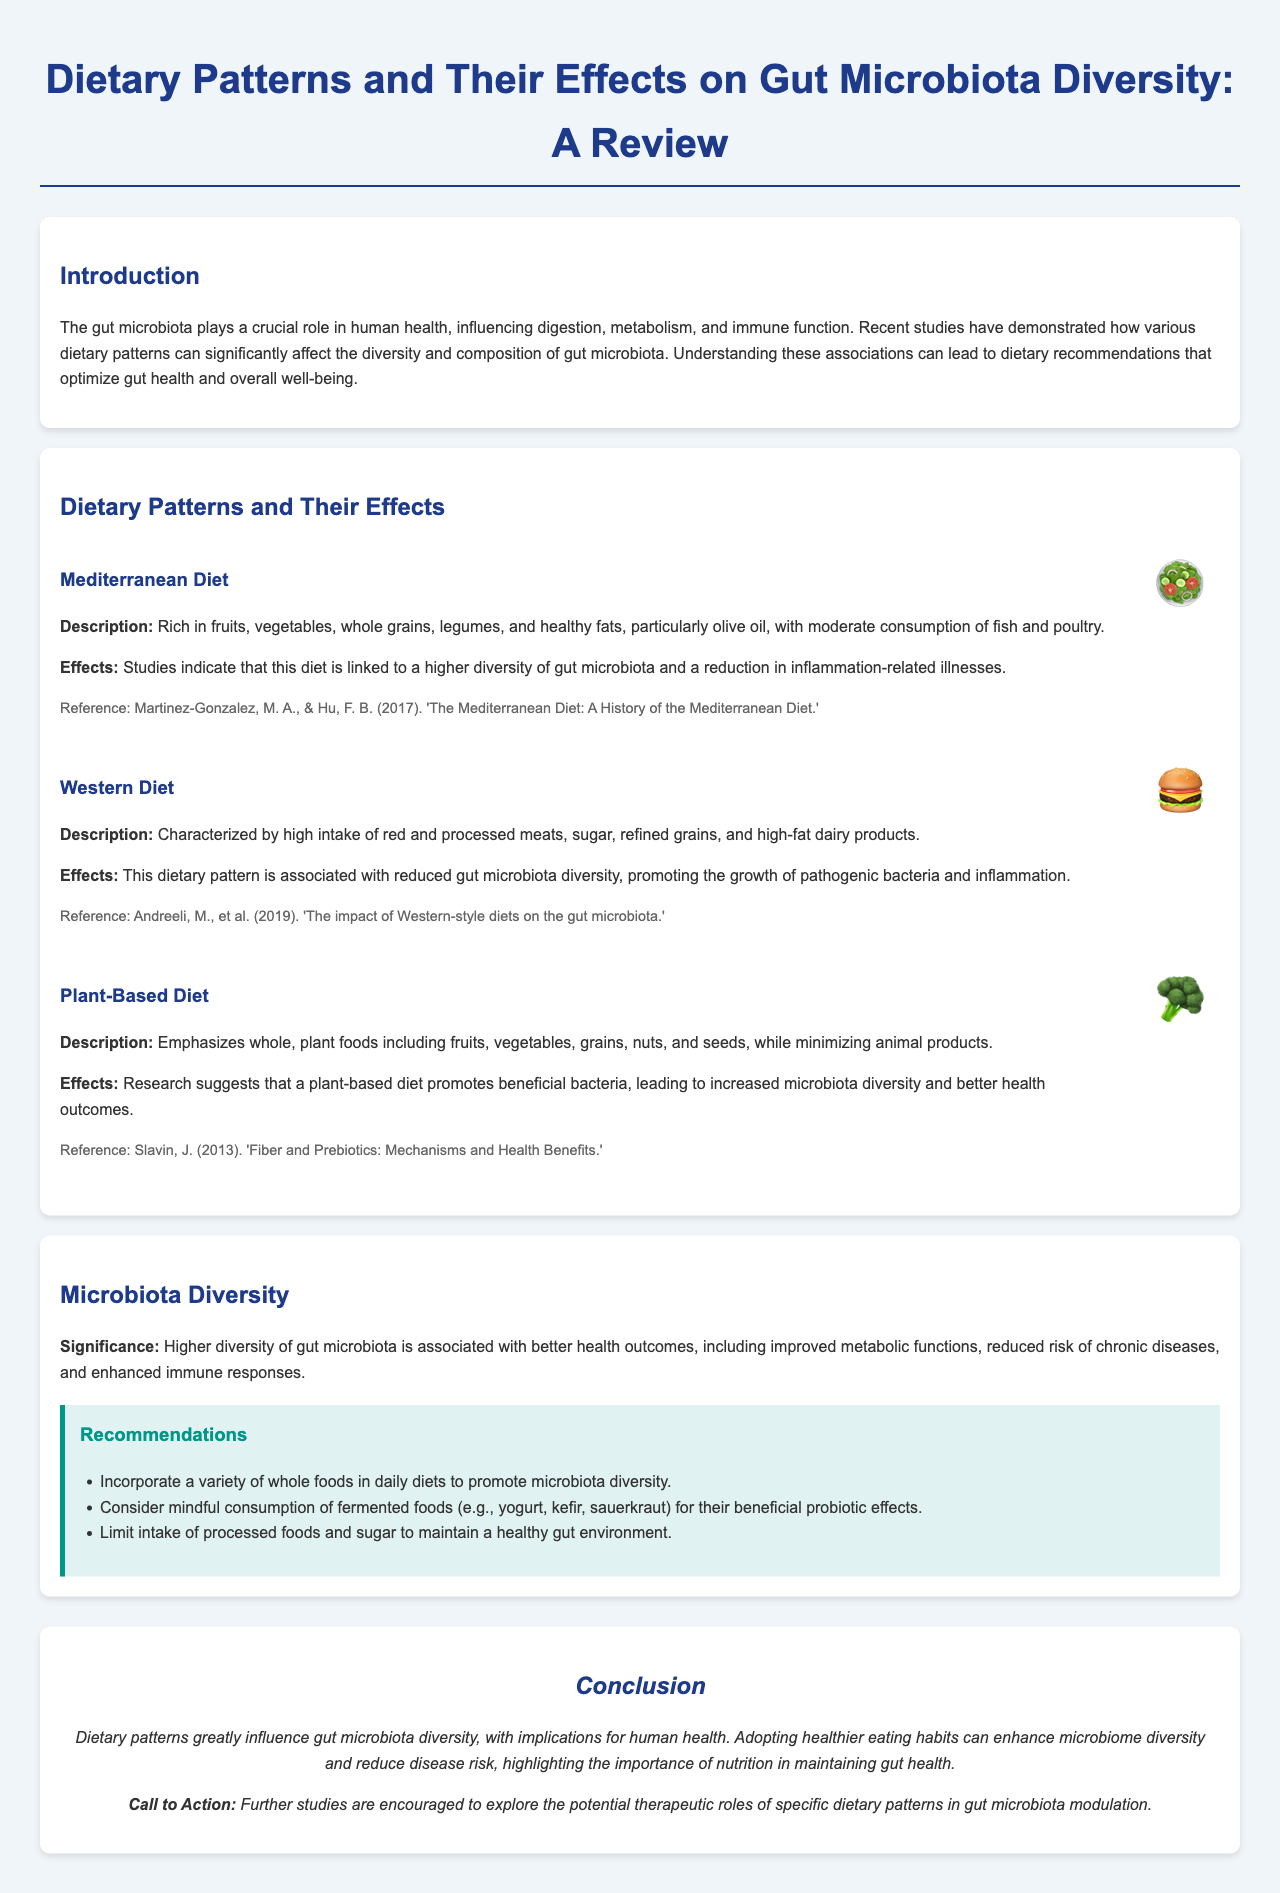What is the main subject of the report? The main subject of the report is the effects of dietary patterns on gut microbiota diversity.
Answer: Dietary patterns and gut microbiota diversity What dietary pattern is associated with higher gut microbiota diversity? The Mediterranean Diet is linked to a higher diversity of gut microbiota.
Answer: Mediterranean Diet What is the effect of the Western Diet on gut microbiota? The Western Diet is associated with reduced gut microbiota diversity.
Answer: Reduced gut microbiota diversity What does a plant-based diet promote? A plant-based diet promotes beneficial bacteria.
Answer: Beneficial bacteria Which foods should be incorporated to promote microbiota diversity? A variety of whole foods should be incorporated into daily diets.
Answer: Variety of whole foods What is the significance of higher gut microbiota diversity? Higher diversity is associated with better health outcomes and reduced risk of chronic diseases.
Answer: Better health outcomes What type of foods are recommended to be limited? Processed foods and sugar should be limited.
Answer: Processed foods and sugar Who are the authors mentioned for the Mediterranean Diet reference? The authors are Martinez-Gonzalez and Hu.
Answer: Martinez-Gonzalez, Hu What is encouraged for future studies according to the conclusion? Further studies are encouraged to explore dietary patterns' therapeutic roles.
Answer: Further studies 